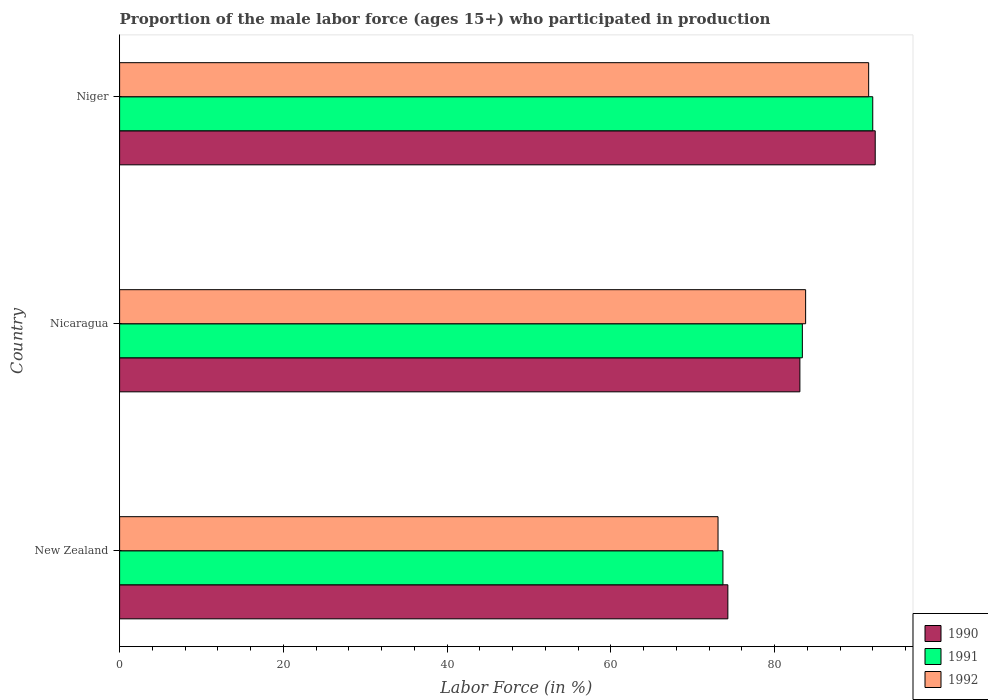Are the number of bars per tick equal to the number of legend labels?
Make the answer very short. Yes. Are the number of bars on each tick of the Y-axis equal?
Offer a very short reply. Yes. How many bars are there on the 2nd tick from the top?
Give a very brief answer. 3. How many bars are there on the 3rd tick from the bottom?
Your response must be concise. 3. What is the label of the 2nd group of bars from the top?
Give a very brief answer. Nicaragua. In how many cases, is the number of bars for a given country not equal to the number of legend labels?
Your answer should be very brief. 0. What is the proportion of the male labor force who participated in production in 1992 in New Zealand?
Your answer should be compact. 73.1. Across all countries, what is the maximum proportion of the male labor force who participated in production in 1992?
Ensure brevity in your answer.  91.5. Across all countries, what is the minimum proportion of the male labor force who participated in production in 1990?
Make the answer very short. 74.3. In which country was the proportion of the male labor force who participated in production in 1991 maximum?
Give a very brief answer. Niger. In which country was the proportion of the male labor force who participated in production in 1992 minimum?
Your answer should be very brief. New Zealand. What is the total proportion of the male labor force who participated in production in 1992 in the graph?
Your answer should be compact. 248.4. What is the difference between the proportion of the male labor force who participated in production in 1991 in Nicaragua and that in Niger?
Provide a short and direct response. -8.6. What is the difference between the proportion of the male labor force who participated in production in 1992 in Nicaragua and the proportion of the male labor force who participated in production in 1990 in Niger?
Make the answer very short. -8.5. What is the average proportion of the male labor force who participated in production in 1992 per country?
Ensure brevity in your answer.  82.8. What is the difference between the proportion of the male labor force who participated in production in 1990 and proportion of the male labor force who participated in production in 1991 in Nicaragua?
Give a very brief answer. -0.3. What is the ratio of the proportion of the male labor force who participated in production in 1991 in New Zealand to that in Niger?
Make the answer very short. 0.8. Is the proportion of the male labor force who participated in production in 1992 in New Zealand less than that in Niger?
Ensure brevity in your answer.  Yes. What is the difference between the highest and the second highest proportion of the male labor force who participated in production in 1990?
Give a very brief answer. 9.2. What is the difference between the highest and the lowest proportion of the male labor force who participated in production in 1991?
Ensure brevity in your answer.  18.3. In how many countries, is the proportion of the male labor force who participated in production in 1991 greater than the average proportion of the male labor force who participated in production in 1991 taken over all countries?
Your answer should be compact. 2. Is the sum of the proportion of the male labor force who participated in production in 1992 in New Zealand and Niger greater than the maximum proportion of the male labor force who participated in production in 1990 across all countries?
Give a very brief answer. Yes. How many countries are there in the graph?
Offer a terse response. 3. What is the difference between two consecutive major ticks on the X-axis?
Provide a short and direct response. 20. Are the values on the major ticks of X-axis written in scientific E-notation?
Provide a short and direct response. No. Does the graph contain any zero values?
Offer a very short reply. No. Where does the legend appear in the graph?
Provide a succinct answer. Bottom right. How are the legend labels stacked?
Ensure brevity in your answer.  Vertical. What is the title of the graph?
Your response must be concise. Proportion of the male labor force (ages 15+) who participated in production. What is the label or title of the X-axis?
Your answer should be very brief. Labor Force (in %). What is the Labor Force (in %) in 1990 in New Zealand?
Your answer should be compact. 74.3. What is the Labor Force (in %) of 1991 in New Zealand?
Your answer should be compact. 73.7. What is the Labor Force (in %) in 1992 in New Zealand?
Provide a short and direct response. 73.1. What is the Labor Force (in %) of 1990 in Nicaragua?
Ensure brevity in your answer.  83.1. What is the Labor Force (in %) in 1991 in Nicaragua?
Ensure brevity in your answer.  83.4. What is the Labor Force (in %) of 1992 in Nicaragua?
Provide a succinct answer. 83.8. What is the Labor Force (in %) in 1990 in Niger?
Give a very brief answer. 92.3. What is the Labor Force (in %) of 1991 in Niger?
Make the answer very short. 92. What is the Labor Force (in %) in 1992 in Niger?
Your answer should be compact. 91.5. Across all countries, what is the maximum Labor Force (in %) in 1990?
Make the answer very short. 92.3. Across all countries, what is the maximum Labor Force (in %) in 1991?
Make the answer very short. 92. Across all countries, what is the maximum Labor Force (in %) of 1992?
Your response must be concise. 91.5. Across all countries, what is the minimum Labor Force (in %) in 1990?
Your answer should be very brief. 74.3. Across all countries, what is the minimum Labor Force (in %) of 1991?
Give a very brief answer. 73.7. Across all countries, what is the minimum Labor Force (in %) of 1992?
Provide a succinct answer. 73.1. What is the total Labor Force (in %) in 1990 in the graph?
Provide a short and direct response. 249.7. What is the total Labor Force (in %) in 1991 in the graph?
Offer a very short reply. 249.1. What is the total Labor Force (in %) of 1992 in the graph?
Offer a terse response. 248.4. What is the difference between the Labor Force (in %) in 1990 in New Zealand and that in Nicaragua?
Your answer should be compact. -8.8. What is the difference between the Labor Force (in %) of 1991 in New Zealand and that in Nicaragua?
Offer a very short reply. -9.7. What is the difference between the Labor Force (in %) of 1990 in New Zealand and that in Niger?
Your answer should be compact. -18. What is the difference between the Labor Force (in %) in 1991 in New Zealand and that in Niger?
Offer a very short reply. -18.3. What is the difference between the Labor Force (in %) of 1992 in New Zealand and that in Niger?
Make the answer very short. -18.4. What is the difference between the Labor Force (in %) in 1990 in Nicaragua and that in Niger?
Make the answer very short. -9.2. What is the difference between the Labor Force (in %) in 1991 in Nicaragua and that in Niger?
Ensure brevity in your answer.  -8.6. What is the difference between the Labor Force (in %) of 1990 in New Zealand and the Labor Force (in %) of 1991 in Nicaragua?
Ensure brevity in your answer.  -9.1. What is the difference between the Labor Force (in %) of 1990 in New Zealand and the Labor Force (in %) of 1992 in Nicaragua?
Provide a short and direct response. -9.5. What is the difference between the Labor Force (in %) of 1990 in New Zealand and the Labor Force (in %) of 1991 in Niger?
Provide a short and direct response. -17.7. What is the difference between the Labor Force (in %) of 1990 in New Zealand and the Labor Force (in %) of 1992 in Niger?
Give a very brief answer. -17.2. What is the difference between the Labor Force (in %) in 1991 in New Zealand and the Labor Force (in %) in 1992 in Niger?
Your answer should be compact. -17.8. What is the difference between the Labor Force (in %) in 1990 in Nicaragua and the Labor Force (in %) in 1991 in Niger?
Make the answer very short. -8.9. What is the difference between the Labor Force (in %) of 1991 in Nicaragua and the Labor Force (in %) of 1992 in Niger?
Your response must be concise. -8.1. What is the average Labor Force (in %) of 1990 per country?
Provide a succinct answer. 83.23. What is the average Labor Force (in %) of 1991 per country?
Give a very brief answer. 83.03. What is the average Labor Force (in %) in 1992 per country?
Keep it short and to the point. 82.8. What is the difference between the Labor Force (in %) in 1991 and Labor Force (in %) in 1992 in Nicaragua?
Offer a terse response. -0.4. What is the difference between the Labor Force (in %) in 1990 and Labor Force (in %) in 1992 in Niger?
Offer a very short reply. 0.8. What is the ratio of the Labor Force (in %) of 1990 in New Zealand to that in Nicaragua?
Give a very brief answer. 0.89. What is the ratio of the Labor Force (in %) of 1991 in New Zealand to that in Nicaragua?
Offer a terse response. 0.88. What is the ratio of the Labor Force (in %) of 1992 in New Zealand to that in Nicaragua?
Keep it short and to the point. 0.87. What is the ratio of the Labor Force (in %) in 1990 in New Zealand to that in Niger?
Provide a short and direct response. 0.81. What is the ratio of the Labor Force (in %) in 1991 in New Zealand to that in Niger?
Your response must be concise. 0.8. What is the ratio of the Labor Force (in %) of 1992 in New Zealand to that in Niger?
Offer a very short reply. 0.8. What is the ratio of the Labor Force (in %) of 1990 in Nicaragua to that in Niger?
Provide a short and direct response. 0.9. What is the ratio of the Labor Force (in %) in 1991 in Nicaragua to that in Niger?
Your answer should be very brief. 0.91. What is the ratio of the Labor Force (in %) of 1992 in Nicaragua to that in Niger?
Ensure brevity in your answer.  0.92. What is the difference between the highest and the second highest Labor Force (in %) of 1990?
Offer a very short reply. 9.2. What is the difference between the highest and the lowest Labor Force (in %) in 1990?
Your answer should be very brief. 18. What is the difference between the highest and the lowest Labor Force (in %) of 1991?
Give a very brief answer. 18.3. 